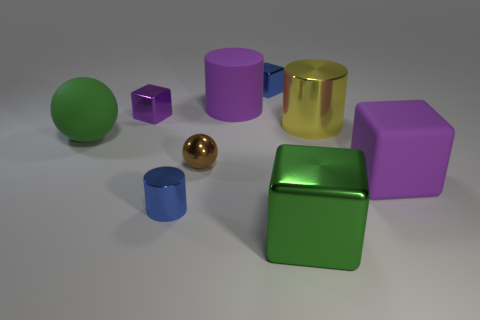There is a tiny cube that is the same color as the large matte cylinder; what is its material?
Offer a terse response. Metal. Are there any tiny yellow matte things of the same shape as the big green shiny object?
Your answer should be compact. No. How many small brown metal objects have the same shape as the small purple thing?
Keep it short and to the point. 0. Does the large metal cylinder have the same color as the small metal cylinder?
Provide a succinct answer. No. Are there fewer tiny green metal cylinders than yellow metallic objects?
Offer a very short reply. Yes. There is a purple cube that is behind the green matte sphere; what is it made of?
Ensure brevity in your answer.  Metal. What material is the cylinder that is the same size as the yellow thing?
Offer a terse response. Rubber. What is the blue block behind the purple cube that is on the right side of the big metal cylinder that is behind the tiny metal cylinder made of?
Make the answer very short. Metal. Does the shiny cube on the left side of the purple rubber cylinder have the same size as the purple cylinder?
Your answer should be very brief. No. Is the number of metal things greater than the number of big purple matte blocks?
Make the answer very short. Yes. 